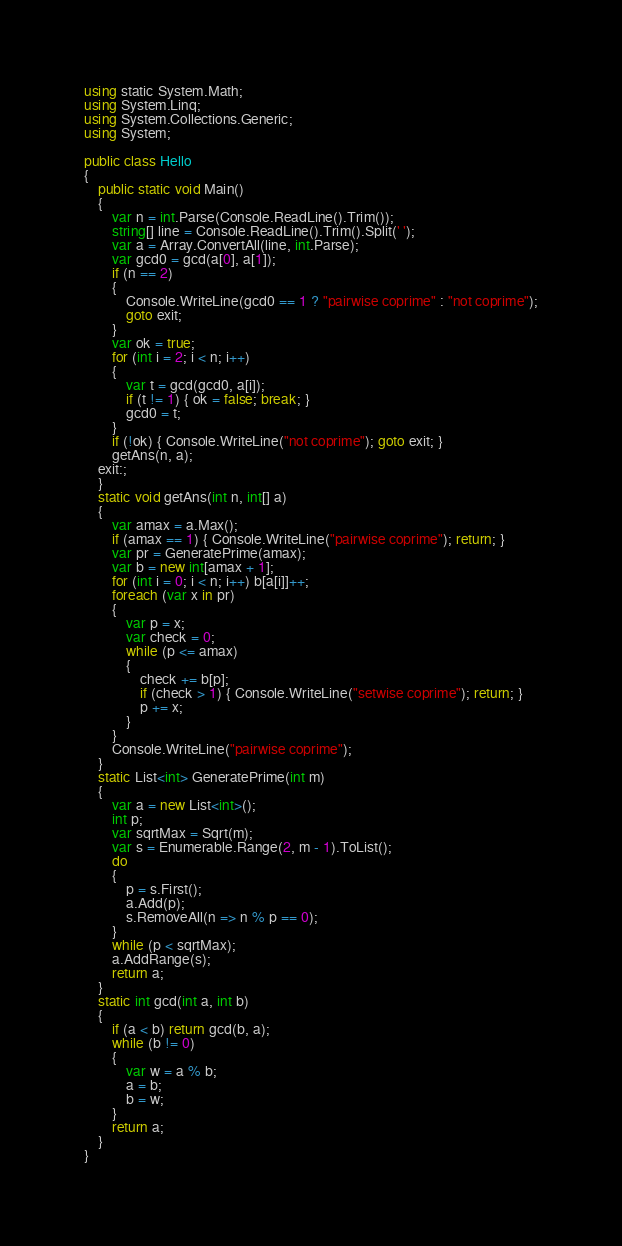<code> <loc_0><loc_0><loc_500><loc_500><_C#_>using static System.Math;
using System.Linq;
using System.Collections.Generic;
using System;

public class Hello
{
    public static void Main()
    {
        var n = int.Parse(Console.ReadLine().Trim());
        string[] line = Console.ReadLine().Trim().Split(' ');
        var a = Array.ConvertAll(line, int.Parse);
        var gcd0 = gcd(a[0], a[1]);
        if (n == 2)
        {
            Console.WriteLine(gcd0 == 1 ? "pairwise coprime" : "not coprime");
            goto exit;
        }
        var ok = true;
        for (int i = 2; i < n; i++)
        {
            var t = gcd(gcd0, a[i]);
            if (t != 1) { ok = false; break; }
            gcd0 = t;
        }
        if (!ok) { Console.WriteLine("not coprime"); goto exit; }
        getAns(n, a);
    exit:;
    }
    static void getAns(int n, int[] a)
    {
        var amax = a.Max();
        if (amax == 1) { Console.WriteLine("pairwise coprime"); return; }
        var pr = GeneratePrime(amax);
        var b = new int[amax + 1];
        for (int i = 0; i < n; i++) b[a[i]]++;
        foreach (var x in pr)
        {
            var p = x;
            var check = 0;
            while (p <= amax)
            {
                check += b[p];
                if (check > 1) { Console.WriteLine("setwise coprime"); return; }
                p += x;
            }
        }
        Console.WriteLine("pairwise coprime");
    }
    static List<int> GeneratePrime(int m)
    {
        var a = new List<int>();
        int p;
        var sqrtMax = Sqrt(m);
        var s = Enumerable.Range(2, m - 1).ToList();
        do
        {
            p = s.First();
            a.Add(p);
            s.RemoveAll(n => n % p == 0);
        }
        while (p < sqrtMax);
        a.AddRange(s);
        return a;
    }
    static int gcd(int a, int b)
    {
        if (a < b) return gcd(b, a);
        while (b != 0)
        {
            var w = a % b;
            a = b;
            b = w;
        }
        return a;
    }
}
</code> 